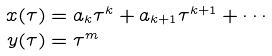<formula> <loc_0><loc_0><loc_500><loc_500>x ( \tau ) & = a _ { k } \tau ^ { k } + a _ { k + 1 } \tau ^ { k + 1 } + \cdots \\ y ( \tau ) & = \tau ^ { m }</formula> 